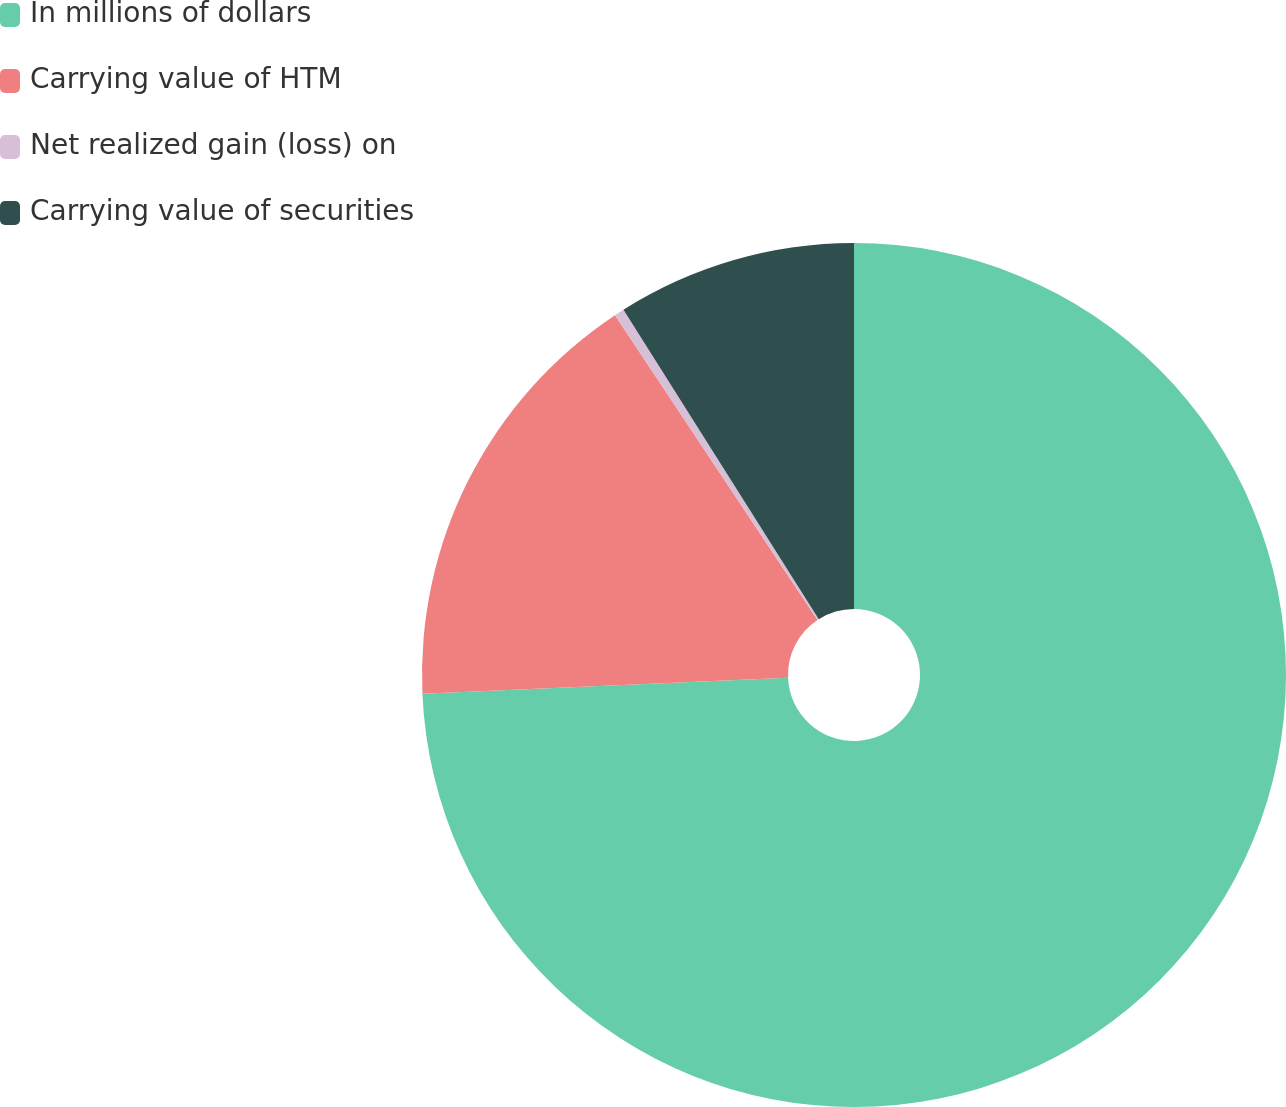Convert chart. <chart><loc_0><loc_0><loc_500><loc_500><pie_chart><fcel>In millions of dollars<fcel>Carrying value of HTM<fcel>Net realized gain (loss) on<fcel>Carrying value of securities<nl><fcel>74.31%<fcel>16.36%<fcel>0.37%<fcel>8.96%<nl></chart> 